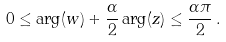Convert formula to latex. <formula><loc_0><loc_0><loc_500><loc_500>0 \leq \arg ( w ) + \frac { \alpha } { 2 } \arg ( z ) \leq \frac { \alpha \pi } { 2 } \, .</formula> 